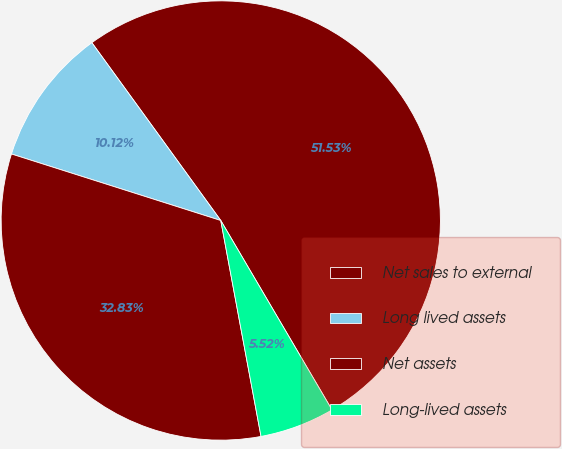Convert chart. <chart><loc_0><loc_0><loc_500><loc_500><pie_chart><fcel>Net sales to external<fcel>Long lived assets<fcel>Net assets<fcel>Long-lived assets<nl><fcel>51.53%<fcel>10.12%<fcel>32.83%<fcel>5.52%<nl></chart> 